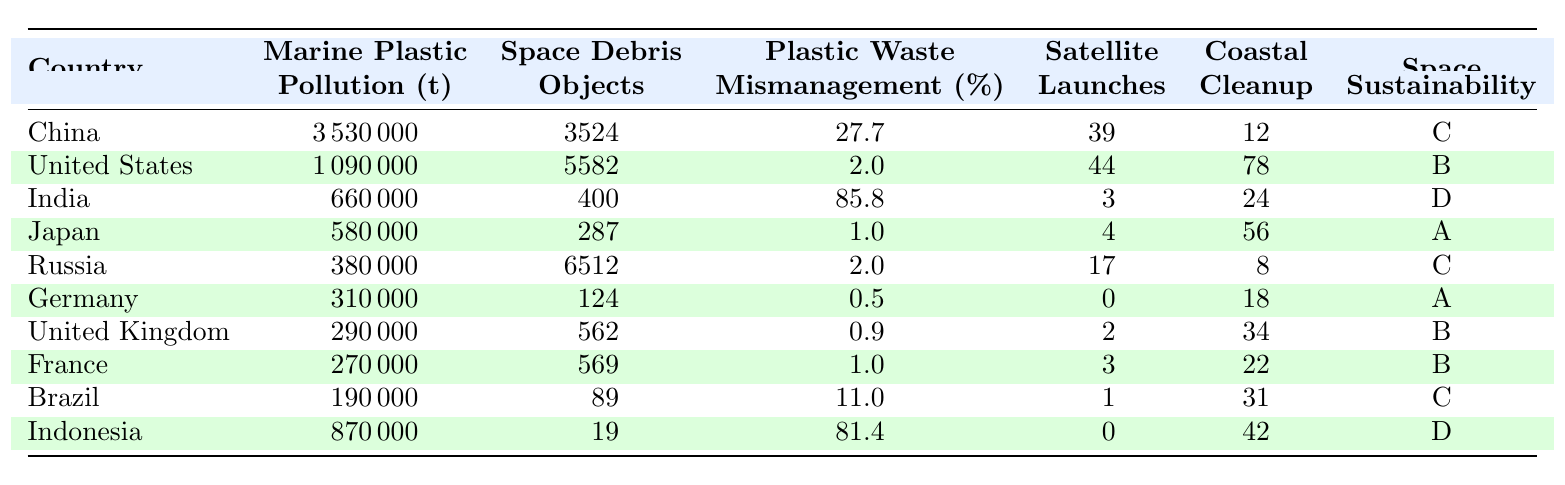What is the total amount of marine plastic pollution from the top two countries combined? The amount of marine plastic pollution from China is 3,530,000 metric tons and from the United States is 1,090,000 metric tons. Adding these together: 3,530,000 + 1,090,000 = 4,620,000 metric tons.
Answer: 4,620,000 metric tons Which country has the highest plastic waste mismanagement rate? By looking at the "Plastic Waste Mismanagement Rate" column, India has the highest rate at 85.8%.
Answer: India How many countries have a space sustainability rating of A? The countries rated A are Japan and Germany. Therefore, there are 2 countries in total with an A rating.
Answer: 2 Is there a relationship between the number of satellite launches and marine plastic pollution? A detailed assessment would be needed, but we note that the United States has the highest number of satellite launches (44) and substantial marine plastic pollution (1,090,000 metric tons), while Germany has no satellite launches but lower pollution (310,000 metric tons). This varies across countries. More research is needed for a conclusion.
Answer: No clear relationship What is the average space debris count for countries with a plastic waste mismanagement rate above 80%? The countries with a plastic waste mismanagement rate above 80% are India (400 objects) and Indonesia (19 objects). The average is calculated by (400 + 19) / 2 = 209.5.
Answer: 209.5 Which country has both the highest amount of space debris and the lowest plastic waste mismanagement rate? Russia has the highest space debris at 6,512 objects, and its plastic waste mismanagement rate is 2.0%, which is low compared to others.
Answer: Russia What is the sum of marine plastic pollution for all countries with a space sustainability rating of B? The countries with a B rating are the United States, United Kingdom, France, and Russia. Their marine plastic pollution amounts to 1,090,000 + 290,000 + 270,000 + 380,000 = 2,030,000 metric tons.
Answer: 2,030,000 metric tons Identify the country with the least amount of marine plastic pollution. From the table, Brazil has the least amount of marine plastic pollution at 190,000 metric tons.
Answer: Brazil How many countries have a plastic waste mismanagement rate of less than 5%? Only Germany has a plastic waste mismanagement rate of 0.5%, making it 1 country with a rate below 5%.
Answer: 1 What is the difference in the number of coastal cleanup initiatives between the country with the highest and the country with the lowest? The United States has 78 coastal cleanup initiatives (highest) and Germany has 18 initiatives (lowest). The difference is 78 - 18 = 60 initiatives.
Answer: 60 initiatives Are all countries with a high amount of marine plastic pollution (> 1 million metric tons) also high in space debris objects? China and the United States have high marine plastic pollution (>1 million), both with substantial space debris (3,524 and 5,582 respectively). However, India, while having high pollution (660,000), has relatively low space debris at 400. Thus, not all meet the second criterion.
Answer: No 